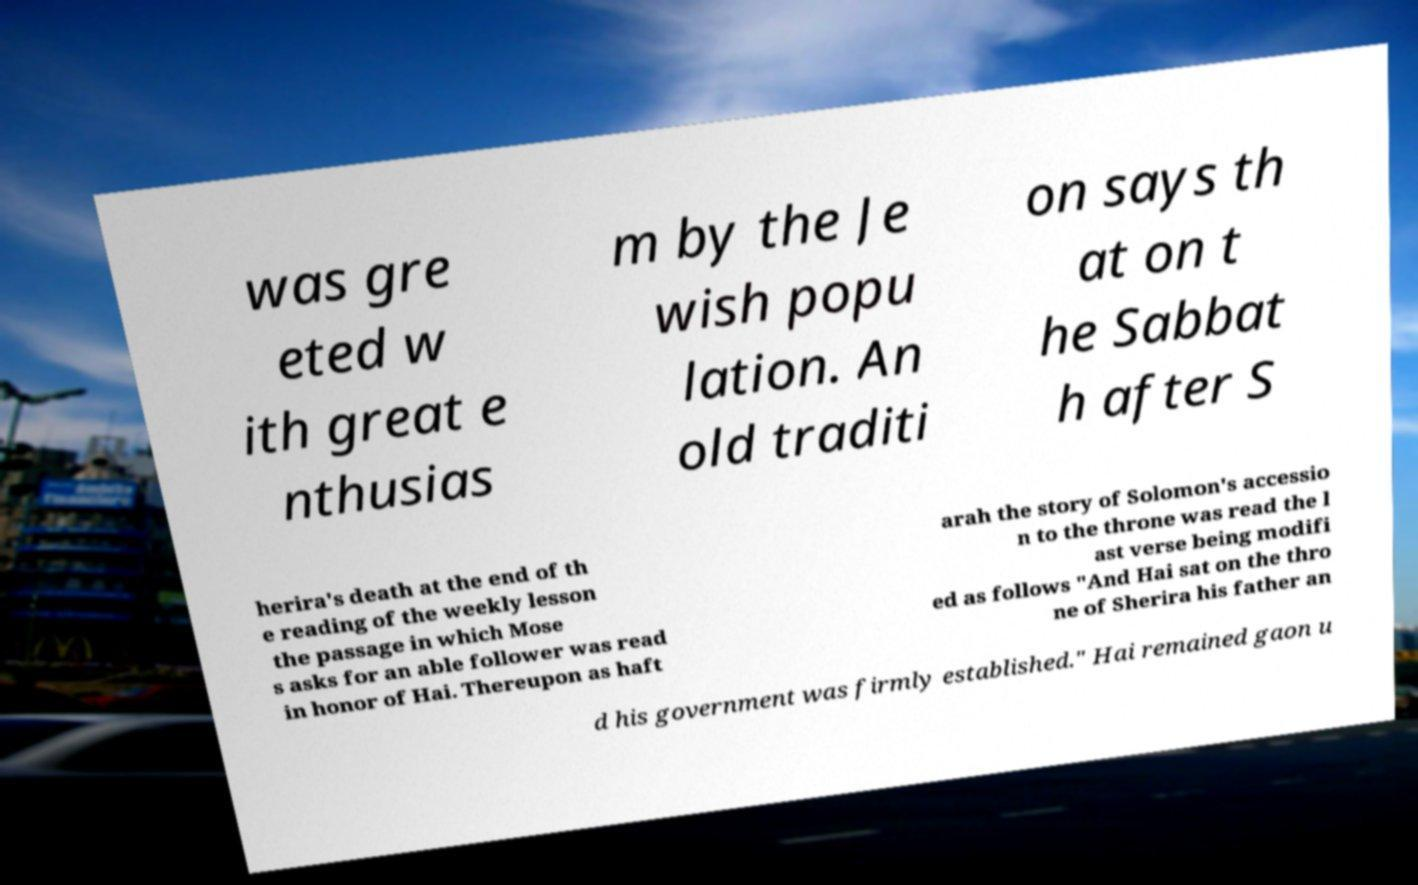Could you assist in decoding the text presented in this image and type it out clearly? was gre eted w ith great e nthusias m by the Je wish popu lation. An old traditi on says th at on t he Sabbat h after S herira's death at the end of th e reading of the weekly lesson the passage in which Mose s asks for an able follower was read in honor of Hai. Thereupon as haft arah the story of Solomon's accessio n to the throne was read the l ast verse being modifi ed as follows "And Hai sat on the thro ne of Sherira his father an d his government was firmly established." Hai remained gaon u 